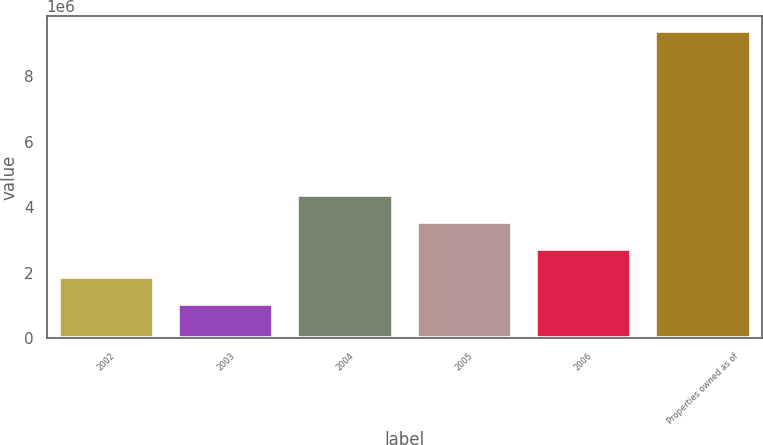Convert chart. <chart><loc_0><loc_0><loc_500><loc_500><bar_chart><fcel>2002<fcel>2003<fcel>2004<fcel>2005<fcel>2006<fcel>Properties owned as of<nl><fcel>1.87966e+06<fcel>1.04608e+06<fcel>4.38039e+06<fcel>3.54681e+06<fcel>2.71323e+06<fcel>9.38186e+06<nl></chart> 